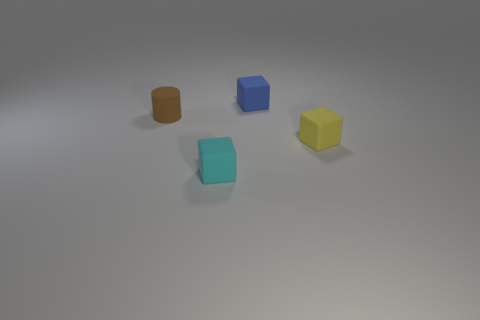Add 4 big brown spheres. How many objects exist? 8 Subtract all blocks. How many objects are left? 1 Subtract all large purple balls. Subtract all yellow matte objects. How many objects are left? 3 Add 1 blue blocks. How many blue blocks are left? 2 Add 4 cyan rubber blocks. How many cyan rubber blocks exist? 5 Subtract 0 red spheres. How many objects are left? 4 